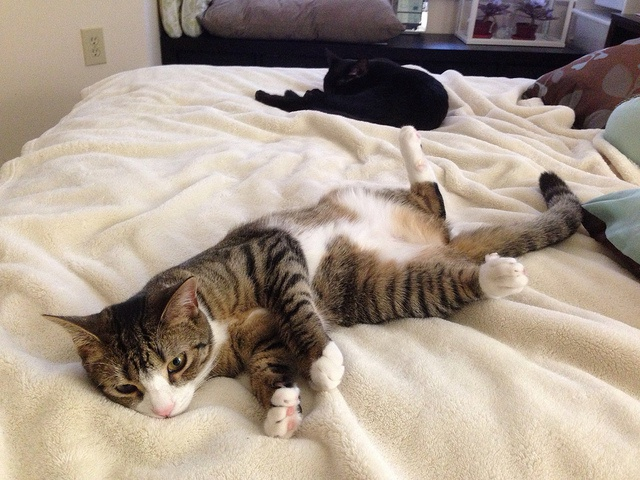Describe the objects in this image and their specific colors. I can see bed in lightgray, tan, and black tones, cat in tan, black, maroon, gray, and lightgray tones, and cat in tan, black, lightgray, darkgray, and gray tones in this image. 